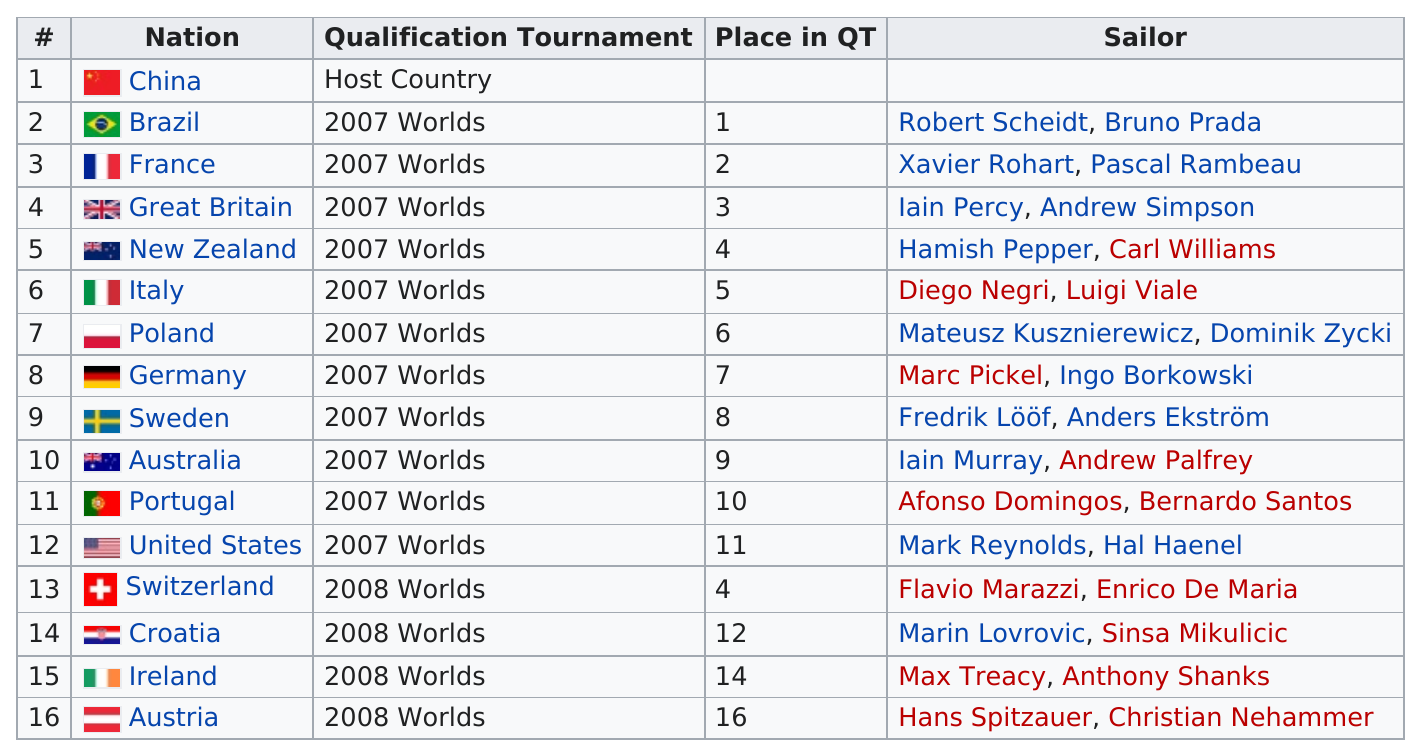Mention a couple of crucial points in this snapshot. The United States came in last place in the 2007 Worlds qualification tournament. During the qualification tournament for the worlds, the average number of sailors per country was 2. Croatia was placed immediately above the United States in the QT. Iain Murray and Andrew Palfrey are sailors who belong to the nation of Australia. Brazil had sailors named Robert Scheidt and Bruno Prada. 